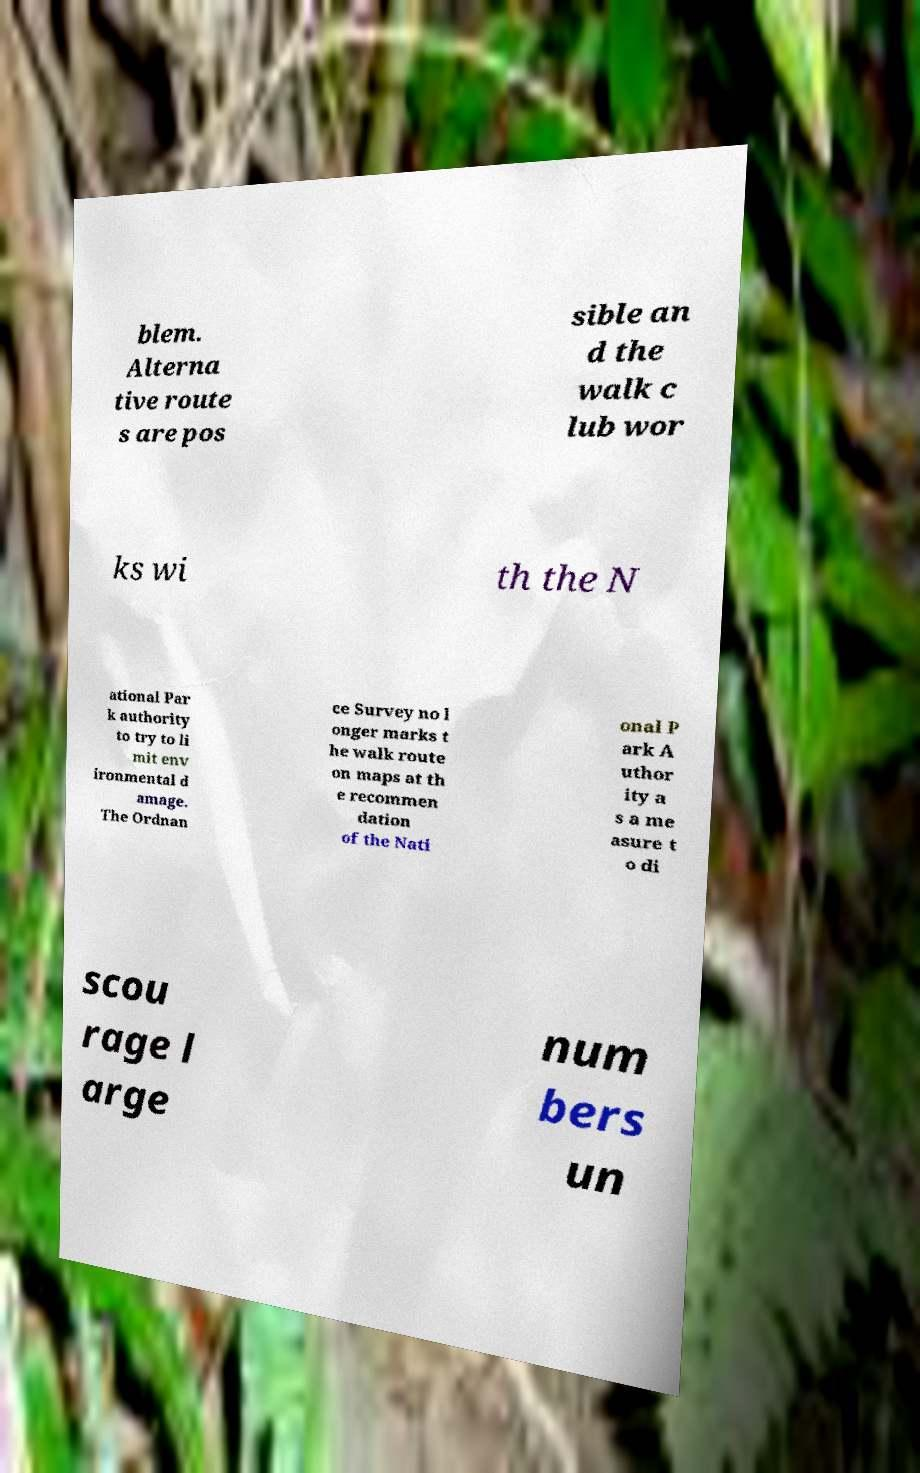Could you extract and type out the text from this image? blem. Alterna tive route s are pos sible an d the walk c lub wor ks wi th the N ational Par k authority to try to li mit env ironmental d amage. The Ordnan ce Survey no l onger marks t he walk route on maps at th e recommen dation of the Nati onal P ark A uthor ity a s a me asure t o di scou rage l arge num bers un 